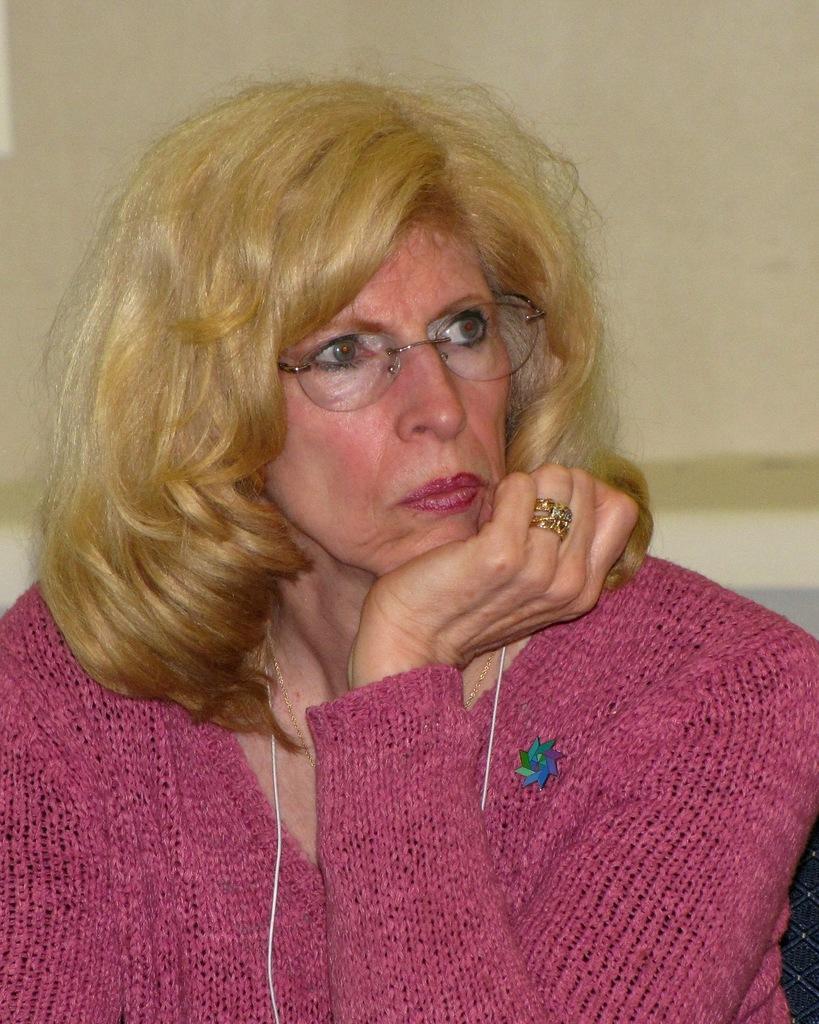Could you give a brief overview of what you see in this image? In this image in the center there is one woman, and in the background there is a wall. 